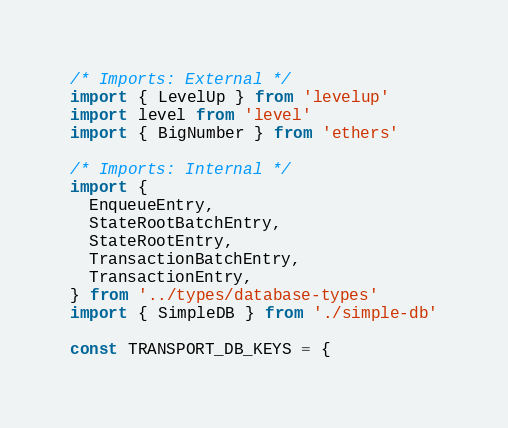Convert code to text. <code><loc_0><loc_0><loc_500><loc_500><_TypeScript_>/* Imports: External */
import { LevelUp } from 'levelup'
import level from 'level'
import { BigNumber } from 'ethers'

/* Imports: Internal */
import {
  EnqueueEntry,
  StateRootBatchEntry,
  StateRootEntry,
  TransactionBatchEntry,
  TransactionEntry,
} from '../types/database-types'
import { SimpleDB } from './simple-db'

const TRANSPORT_DB_KEYS = {</code> 